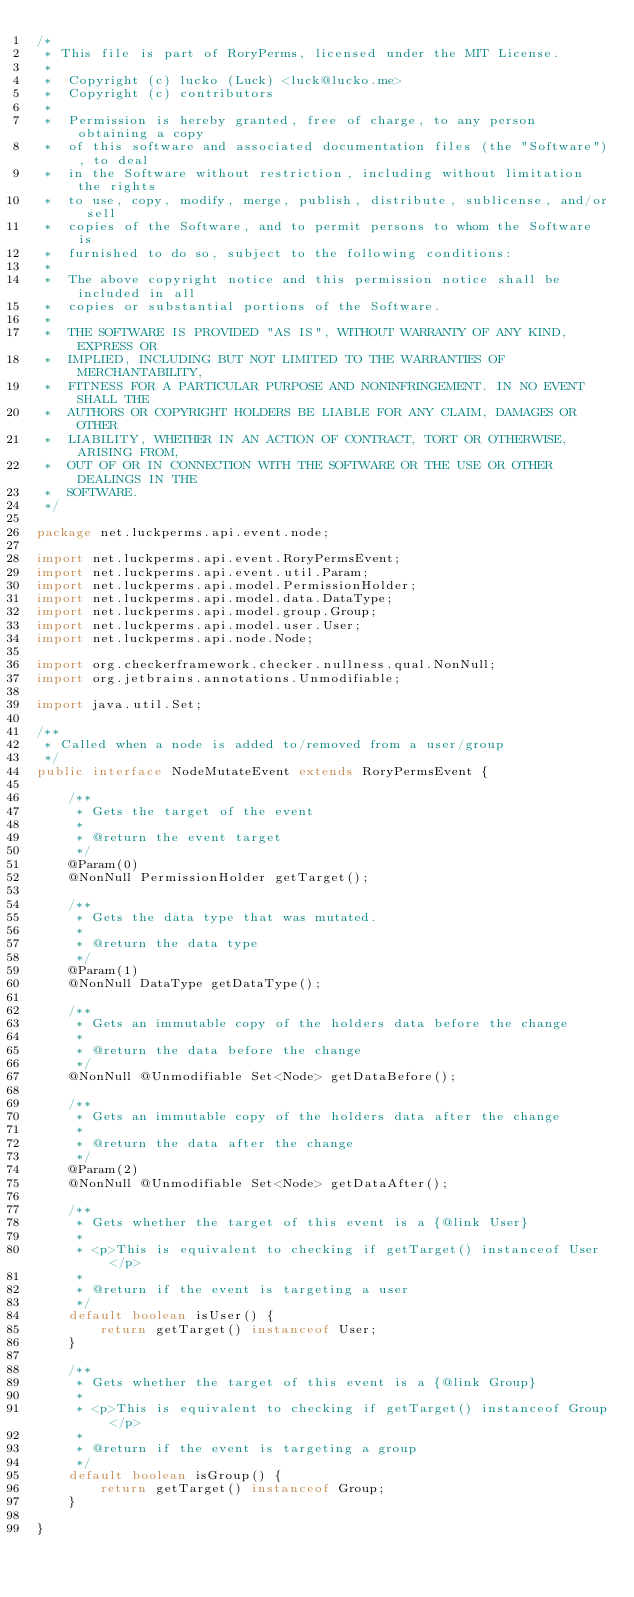<code> <loc_0><loc_0><loc_500><loc_500><_Java_>/*
 * This file is part of RoryPerms, licensed under the MIT License.
 *
 *  Copyright (c) lucko (Luck) <luck@lucko.me>
 *  Copyright (c) contributors
 *
 *  Permission is hereby granted, free of charge, to any person obtaining a copy
 *  of this software and associated documentation files (the "Software"), to deal
 *  in the Software without restriction, including without limitation the rights
 *  to use, copy, modify, merge, publish, distribute, sublicense, and/or sell
 *  copies of the Software, and to permit persons to whom the Software is
 *  furnished to do so, subject to the following conditions:
 *
 *  The above copyright notice and this permission notice shall be included in all
 *  copies or substantial portions of the Software.
 *
 *  THE SOFTWARE IS PROVIDED "AS IS", WITHOUT WARRANTY OF ANY KIND, EXPRESS OR
 *  IMPLIED, INCLUDING BUT NOT LIMITED TO THE WARRANTIES OF MERCHANTABILITY,
 *  FITNESS FOR A PARTICULAR PURPOSE AND NONINFRINGEMENT. IN NO EVENT SHALL THE
 *  AUTHORS OR COPYRIGHT HOLDERS BE LIABLE FOR ANY CLAIM, DAMAGES OR OTHER
 *  LIABILITY, WHETHER IN AN ACTION OF CONTRACT, TORT OR OTHERWISE, ARISING FROM,
 *  OUT OF OR IN CONNECTION WITH THE SOFTWARE OR THE USE OR OTHER DEALINGS IN THE
 *  SOFTWARE.
 */

package net.luckperms.api.event.node;

import net.luckperms.api.event.RoryPermsEvent;
import net.luckperms.api.event.util.Param;
import net.luckperms.api.model.PermissionHolder;
import net.luckperms.api.model.data.DataType;
import net.luckperms.api.model.group.Group;
import net.luckperms.api.model.user.User;
import net.luckperms.api.node.Node;

import org.checkerframework.checker.nullness.qual.NonNull;
import org.jetbrains.annotations.Unmodifiable;

import java.util.Set;

/**
 * Called when a node is added to/removed from a user/group
 */
public interface NodeMutateEvent extends RoryPermsEvent {

    /**
     * Gets the target of the event
     *
     * @return the event target
     */
    @Param(0)
    @NonNull PermissionHolder getTarget();

    /**
     * Gets the data type that was mutated.
     *
     * @return the data type
     */
    @Param(1)
    @NonNull DataType getDataType();

    /**
     * Gets an immutable copy of the holders data before the change
     *
     * @return the data before the change
     */
    @NonNull @Unmodifiable Set<Node> getDataBefore();

    /**
     * Gets an immutable copy of the holders data after the change
     *
     * @return the data after the change
     */
    @Param(2)
    @NonNull @Unmodifiable Set<Node> getDataAfter();

    /**
     * Gets whether the target of this event is a {@link User}
     *
     * <p>This is equivalent to checking if getTarget() instanceof User</p>
     *
     * @return if the event is targeting a user
     */
    default boolean isUser() {
        return getTarget() instanceof User;
    }

    /**
     * Gets whether the target of this event is a {@link Group}
     *
     * <p>This is equivalent to checking if getTarget() instanceof Group</p>
     *
     * @return if the event is targeting a group
     */
    default boolean isGroup() {
        return getTarget() instanceof Group;
    }

}
</code> 